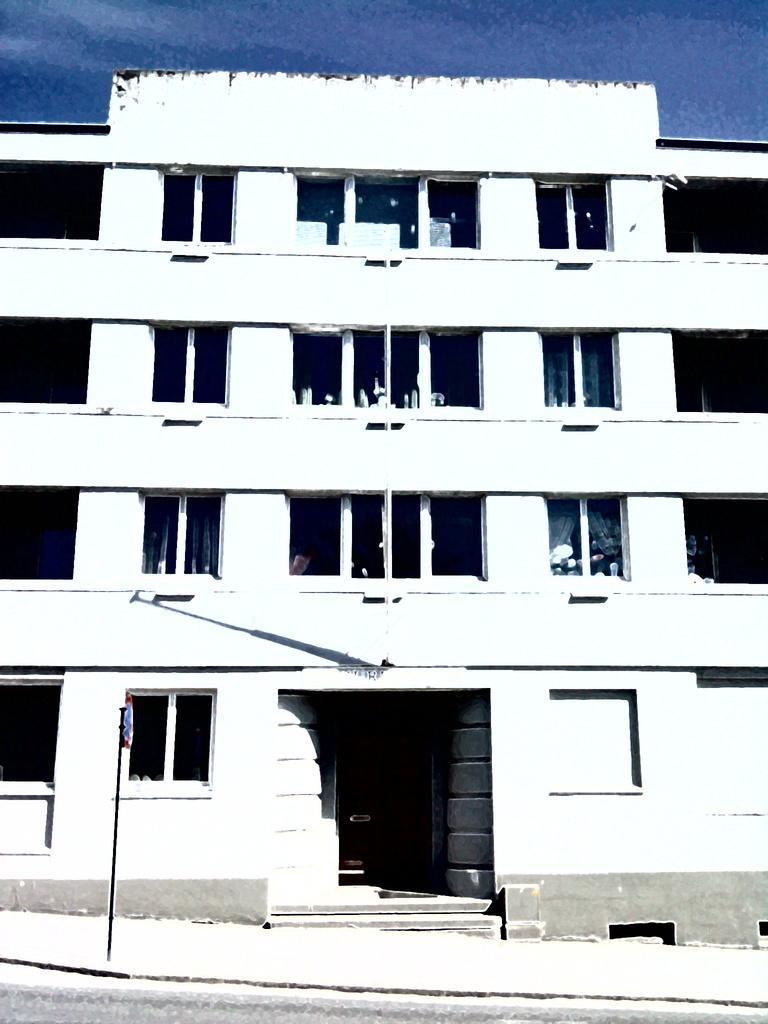How would you summarize this image in a sentence or two? In front of the image there is a road. There is a pole. In the background of the image there is a building. At the top of the image there is sky. 